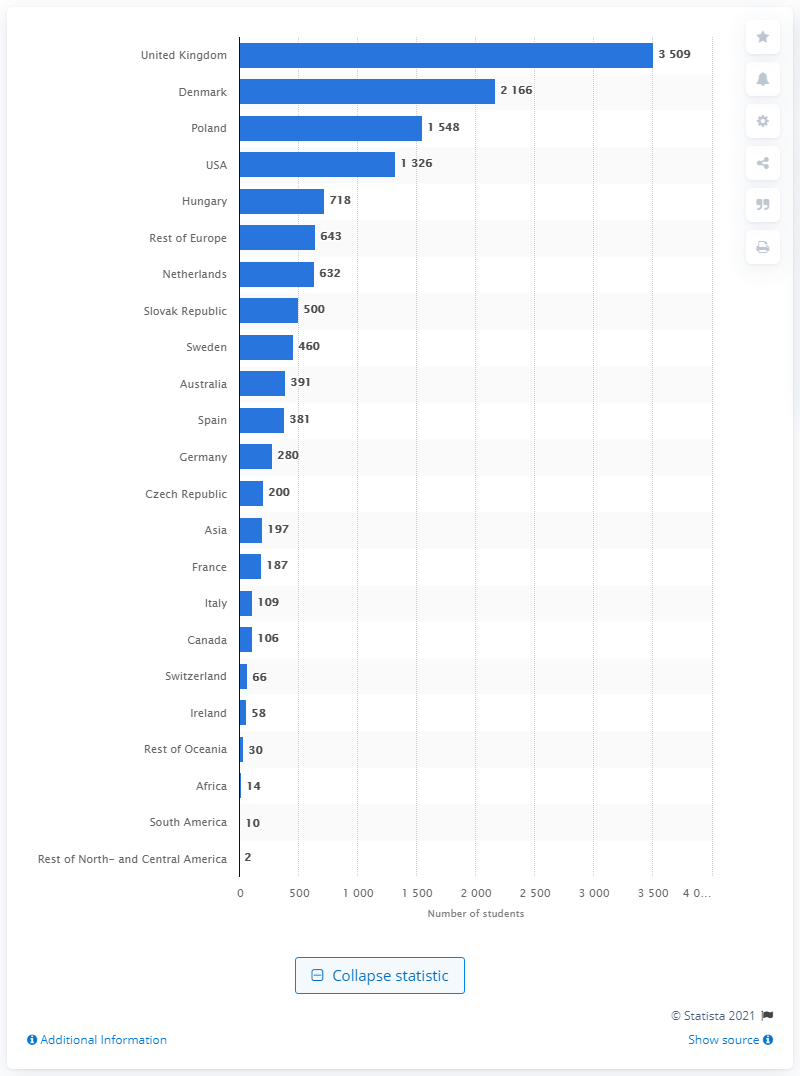Identify some key points in this picture. In 2020, Poland was the third most visited country by Norwegian students. The second most popular destination for Norwegian students in 2020 was Denmark. 